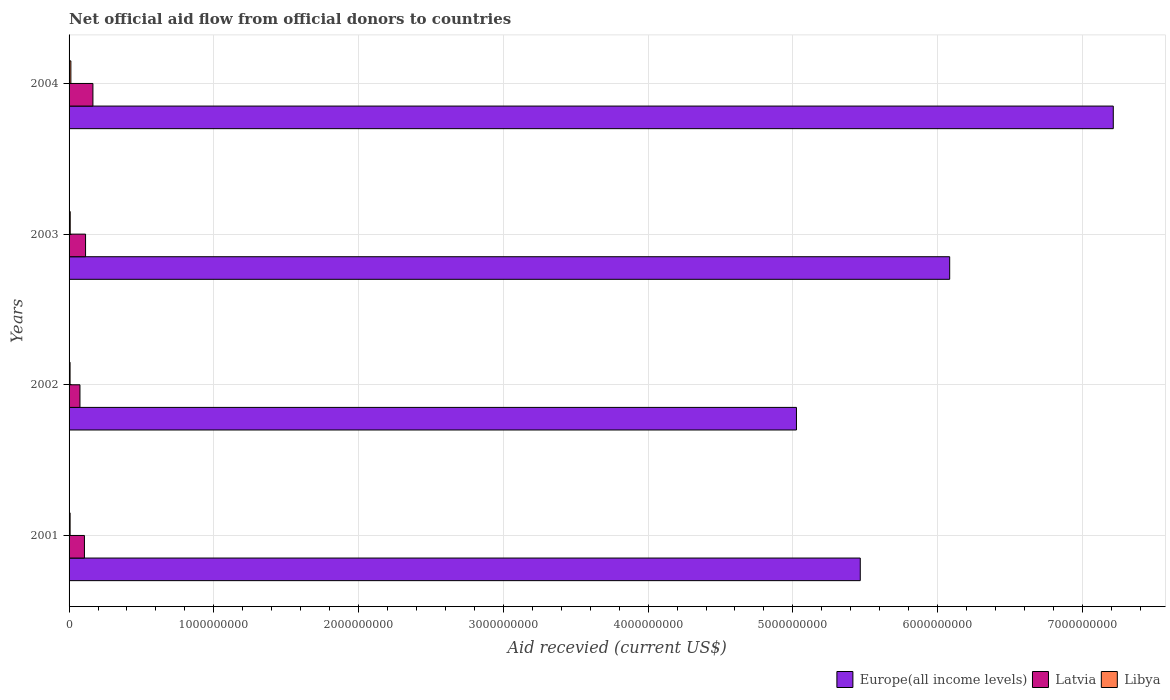How many different coloured bars are there?
Offer a terse response. 3. Are the number of bars per tick equal to the number of legend labels?
Ensure brevity in your answer.  Yes. Are the number of bars on each tick of the Y-axis equal?
Your response must be concise. Yes. How many bars are there on the 1st tick from the top?
Your answer should be very brief. 3. How many bars are there on the 4th tick from the bottom?
Provide a short and direct response. 3. In how many cases, is the number of bars for a given year not equal to the number of legend labels?
Your answer should be very brief. 0. What is the total aid received in Latvia in 2004?
Your answer should be very brief. 1.65e+08. Across all years, what is the maximum total aid received in Libya?
Keep it short and to the point. 1.24e+07. Across all years, what is the minimum total aid received in Europe(all income levels)?
Provide a succinct answer. 5.02e+09. What is the total total aid received in Latvia in the graph?
Provide a succinct answer. 4.60e+08. What is the difference between the total aid received in Europe(all income levels) in 2001 and that in 2003?
Offer a terse response. -6.18e+08. What is the difference between the total aid received in Libya in 2004 and the total aid received in Europe(all income levels) in 2003?
Keep it short and to the point. -6.07e+09. What is the average total aid received in Libya per year?
Keep it short and to the point. 8.60e+06. In the year 2001, what is the difference between the total aid received in Libya and total aid received in Europe(all income levels)?
Your answer should be compact. -5.46e+09. What is the ratio of the total aid received in Europe(all income levels) in 2001 to that in 2002?
Ensure brevity in your answer.  1.09. Is the difference between the total aid received in Libya in 2001 and 2004 greater than the difference between the total aid received in Europe(all income levels) in 2001 and 2004?
Keep it short and to the point. Yes. What is the difference between the highest and the second highest total aid received in Latvia?
Ensure brevity in your answer.  5.08e+07. What is the difference between the highest and the lowest total aid received in Libya?
Offer a very short reply. 5.55e+06. Is the sum of the total aid received in Latvia in 2002 and 2003 greater than the maximum total aid received in Europe(all income levels) across all years?
Provide a succinct answer. No. What does the 3rd bar from the top in 2002 represents?
Make the answer very short. Europe(all income levels). What does the 1st bar from the bottom in 2003 represents?
Give a very brief answer. Europe(all income levels). Are all the bars in the graph horizontal?
Keep it short and to the point. Yes. Are the values on the major ticks of X-axis written in scientific E-notation?
Provide a short and direct response. No. Does the graph contain grids?
Offer a terse response. Yes. How many legend labels are there?
Provide a succinct answer. 3. What is the title of the graph?
Offer a terse response. Net official aid flow from official donors to countries. What is the label or title of the X-axis?
Give a very brief answer. Aid recevied (current US$). What is the Aid recevied (current US$) in Europe(all income levels) in 2001?
Give a very brief answer. 5.47e+09. What is the Aid recevied (current US$) in Latvia in 2001?
Your answer should be very brief. 1.06e+08. What is the Aid recevied (current US$) in Libya in 2001?
Offer a very short reply. 7.14e+06. What is the Aid recevied (current US$) of Europe(all income levels) in 2002?
Your response must be concise. 5.02e+09. What is the Aid recevied (current US$) in Latvia in 2002?
Make the answer very short. 7.52e+07. What is the Aid recevied (current US$) in Libya in 2002?
Keep it short and to the point. 6.88e+06. What is the Aid recevied (current US$) in Europe(all income levels) in 2003?
Offer a terse response. 6.08e+09. What is the Aid recevied (current US$) in Latvia in 2003?
Your answer should be compact. 1.14e+08. What is the Aid recevied (current US$) of Libya in 2003?
Ensure brevity in your answer.  7.95e+06. What is the Aid recevied (current US$) of Europe(all income levels) in 2004?
Provide a succinct answer. 7.21e+09. What is the Aid recevied (current US$) of Latvia in 2004?
Your response must be concise. 1.65e+08. What is the Aid recevied (current US$) in Libya in 2004?
Your answer should be compact. 1.24e+07. Across all years, what is the maximum Aid recevied (current US$) of Europe(all income levels)?
Provide a succinct answer. 7.21e+09. Across all years, what is the maximum Aid recevied (current US$) of Latvia?
Provide a short and direct response. 1.65e+08. Across all years, what is the maximum Aid recevied (current US$) of Libya?
Provide a short and direct response. 1.24e+07. Across all years, what is the minimum Aid recevied (current US$) in Europe(all income levels)?
Your answer should be compact. 5.02e+09. Across all years, what is the minimum Aid recevied (current US$) in Latvia?
Offer a very short reply. 7.52e+07. Across all years, what is the minimum Aid recevied (current US$) of Libya?
Offer a very short reply. 6.88e+06. What is the total Aid recevied (current US$) of Europe(all income levels) in the graph?
Your answer should be compact. 2.38e+1. What is the total Aid recevied (current US$) in Latvia in the graph?
Provide a succinct answer. 4.60e+08. What is the total Aid recevied (current US$) in Libya in the graph?
Keep it short and to the point. 3.44e+07. What is the difference between the Aid recevied (current US$) in Europe(all income levels) in 2001 and that in 2002?
Your response must be concise. 4.41e+08. What is the difference between the Aid recevied (current US$) in Latvia in 2001 and that in 2002?
Keep it short and to the point. 3.09e+07. What is the difference between the Aid recevied (current US$) in Libya in 2001 and that in 2002?
Provide a succinct answer. 2.60e+05. What is the difference between the Aid recevied (current US$) of Europe(all income levels) in 2001 and that in 2003?
Provide a succinct answer. -6.18e+08. What is the difference between the Aid recevied (current US$) in Latvia in 2001 and that in 2003?
Give a very brief answer. -7.80e+06. What is the difference between the Aid recevied (current US$) in Libya in 2001 and that in 2003?
Ensure brevity in your answer.  -8.10e+05. What is the difference between the Aid recevied (current US$) of Europe(all income levels) in 2001 and that in 2004?
Provide a short and direct response. -1.75e+09. What is the difference between the Aid recevied (current US$) of Latvia in 2001 and that in 2004?
Ensure brevity in your answer.  -5.86e+07. What is the difference between the Aid recevied (current US$) in Libya in 2001 and that in 2004?
Your response must be concise. -5.29e+06. What is the difference between the Aid recevied (current US$) of Europe(all income levels) in 2002 and that in 2003?
Provide a succinct answer. -1.06e+09. What is the difference between the Aid recevied (current US$) of Latvia in 2002 and that in 2003?
Your response must be concise. -3.87e+07. What is the difference between the Aid recevied (current US$) of Libya in 2002 and that in 2003?
Provide a short and direct response. -1.07e+06. What is the difference between the Aid recevied (current US$) in Europe(all income levels) in 2002 and that in 2004?
Your answer should be very brief. -2.19e+09. What is the difference between the Aid recevied (current US$) in Latvia in 2002 and that in 2004?
Make the answer very short. -8.95e+07. What is the difference between the Aid recevied (current US$) in Libya in 2002 and that in 2004?
Your response must be concise. -5.55e+06. What is the difference between the Aid recevied (current US$) of Europe(all income levels) in 2003 and that in 2004?
Provide a succinct answer. -1.13e+09. What is the difference between the Aid recevied (current US$) in Latvia in 2003 and that in 2004?
Your answer should be compact. -5.08e+07. What is the difference between the Aid recevied (current US$) in Libya in 2003 and that in 2004?
Make the answer very short. -4.48e+06. What is the difference between the Aid recevied (current US$) of Europe(all income levels) in 2001 and the Aid recevied (current US$) of Latvia in 2002?
Keep it short and to the point. 5.39e+09. What is the difference between the Aid recevied (current US$) in Europe(all income levels) in 2001 and the Aid recevied (current US$) in Libya in 2002?
Ensure brevity in your answer.  5.46e+09. What is the difference between the Aid recevied (current US$) of Latvia in 2001 and the Aid recevied (current US$) of Libya in 2002?
Ensure brevity in your answer.  9.93e+07. What is the difference between the Aid recevied (current US$) of Europe(all income levels) in 2001 and the Aid recevied (current US$) of Latvia in 2003?
Keep it short and to the point. 5.35e+09. What is the difference between the Aid recevied (current US$) of Europe(all income levels) in 2001 and the Aid recevied (current US$) of Libya in 2003?
Your answer should be very brief. 5.46e+09. What is the difference between the Aid recevied (current US$) in Latvia in 2001 and the Aid recevied (current US$) in Libya in 2003?
Your answer should be very brief. 9.82e+07. What is the difference between the Aid recevied (current US$) of Europe(all income levels) in 2001 and the Aid recevied (current US$) of Latvia in 2004?
Keep it short and to the point. 5.30e+09. What is the difference between the Aid recevied (current US$) of Europe(all income levels) in 2001 and the Aid recevied (current US$) of Libya in 2004?
Offer a terse response. 5.45e+09. What is the difference between the Aid recevied (current US$) in Latvia in 2001 and the Aid recevied (current US$) in Libya in 2004?
Ensure brevity in your answer.  9.37e+07. What is the difference between the Aid recevied (current US$) of Europe(all income levels) in 2002 and the Aid recevied (current US$) of Latvia in 2003?
Keep it short and to the point. 4.91e+09. What is the difference between the Aid recevied (current US$) in Europe(all income levels) in 2002 and the Aid recevied (current US$) in Libya in 2003?
Your answer should be compact. 5.02e+09. What is the difference between the Aid recevied (current US$) of Latvia in 2002 and the Aid recevied (current US$) of Libya in 2003?
Ensure brevity in your answer.  6.72e+07. What is the difference between the Aid recevied (current US$) in Europe(all income levels) in 2002 and the Aid recevied (current US$) in Latvia in 2004?
Provide a succinct answer. 4.86e+09. What is the difference between the Aid recevied (current US$) in Europe(all income levels) in 2002 and the Aid recevied (current US$) in Libya in 2004?
Offer a very short reply. 5.01e+09. What is the difference between the Aid recevied (current US$) of Latvia in 2002 and the Aid recevied (current US$) of Libya in 2004?
Provide a short and direct response. 6.28e+07. What is the difference between the Aid recevied (current US$) in Europe(all income levels) in 2003 and the Aid recevied (current US$) in Latvia in 2004?
Keep it short and to the point. 5.92e+09. What is the difference between the Aid recevied (current US$) in Europe(all income levels) in 2003 and the Aid recevied (current US$) in Libya in 2004?
Your response must be concise. 6.07e+09. What is the difference between the Aid recevied (current US$) in Latvia in 2003 and the Aid recevied (current US$) in Libya in 2004?
Ensure brevity in your answer.  1.02e+08. What is the average Aid recevied (current US$) of Europe(all income levels) per year?
Offer a terse response. 5.95e+09. What is the average Aid recevied (current US$) of Latvia per year?
Give a very brief answer. 1.15e+08. What is the average Aid recevied (current US$) in Libya per year?
Your response must be concise. 8.60e+06. In the year 2001, what is the difference between the Aid recevied (current US$) in Europe(all income levels) and Aid recevied (current US$) in Latvia?
Make the answer very short. 5.36e+09. In the year 2001, what is the difference between the Aid recevied (current US$) in Europe(all income levels) and Aid recevied (current US$) in Libya?
Ensure brevity in your answer.  5.46e+09. In the year 2001, what is the difference between the Aid recevied (current US$) in Latvia and Aid recevied (current US$) in Libya?
Give a very brief answer. 9.90e+07. In the year 2002, what is the difference between the Aid recevied (current US$) in Europe(all income levels) and Aid recevied (current US$) in Latvia?
Your answer should be very brief. 4.95e+09. In the year 2002, what is the difference between the Aid recevied (current US$) of Europe(all income levels) and Aid recevied (current US$) of Libya?
Keep it short and to the point. 5.02e+09. In the year 2002, what is the difference between the Aid recevied (current US$) of Latvia and Aid recevied (current US$) of Libya?
Make the answer very short. 6.83e+07. In the year 2003, what is the difference between the Aid recevied (current US$) of Europe(all income levels) and Aid recevied (current US$) of Latvia?
Provide a short and direct response. 5.97e+09. In the year 2003, what is the difference between the Aid recevied (current US$) in Europe(all income levels) and Aid recevied (current US$) in Libya?
Offer a very short reply. 6.08e+09. In the year 2003, what is the difference between the Aid recevied (current US$) of Latvia and Aid recevied (current US$) of Libya?
Your answer should be compact. 1.06e+08. In the year 2004, what is the difference between the Aid recevied (current US$) of Europe(all income levels) and Aid recevied (current US$) of Latvia?
Ensure brevity in your answer.  7.05e+09. In the year 2004, what is the difference between the Aid recevied (current US$) in Europe(all income levels) and Aid recevied (current US$) in Libya?
Provide a short and direct response. 7.20e+09. In the year 2004, what is the difference between the Aid recevied (current US$) of Latvia and Aid recevied (current US$) of Libya?
Your answer should be very brief. 1.52e+08. What is the ratio of the Aid recevied (current US$) of Europe(all income levels) in 2001 to that in 2002?
Keep it short and to the point. 1.09. What is the ratio of the Aid recevied (current US$) in Latvia in 2001 to that in 2002?
Keep it short and to the point. 1.41. What is the ratio of the Aid recevied (current US$) of Libya in 2001 to that in 2002?
Ensure brevity in your answer.  1.04. What is the ratio of the Aid recevied (current US$) in Europe(all income levels) in 2001 to that in 2003?
Give a very brief answer. 0.9. What is the ratio of the Aid recevied (current US$) of Latvia in 2001 to that in 2003?
Offer a terse response. 0.93. What is the ratio of the Aid recevied (current US$) of Libya in 2001 to that in 2003?
Offer a terse response. 0.9. What is the ratio of the Aid recevied (current US$) of Europe(all income levels) in 2001 to that in 2004?
Ensure brevity in your answer.  0.76. What is the ratio of the Aid recevied (current US$) in Latvia in 2001 to that in 2004?
Your answer should be compact. 0.64. What is the ratio of the Aid recevied (current US$) in Libya in 2001 to that in 2004?
Offer a very short reply. 0.57. What is the ratio of the Aid recevied (current US$) of Europe(all income levels) in 2002 to that in 2003?
Your answer should be very brief. 0.83. What is the ratio of the Aid recevied (current US$) in Latvia in 2002 to that in 2003?
Provide a succinct answer. 0.66. What is the ratio of the Aid recevied (current US$) in Libya in 2002 to that in 2003?
Your answer should be compact. 0.87. What is the ratio of the Aid recevied (current US$) of Europe(all income levels) in 2002 to that in 2004?
Provide a succinct answer. 0.7. What is the ratio of the Aid recevied (current US$) of Latvia in 2002 to that in 2004?
Provide a short and direct response. 0.46. What is the ratio of the Aid recevied (current US$) in Libya in 2002 to that in 2004?
Provide a short and direct response. 0.55. What is the ratio of the Aid recevied (current US$) in Europe(all income levels) in 2003 to that in 2004?
Offer a very short reply. 0.84. What is the ratio of the Aid recevied (current US$) of Latvia in 2003 to that in 2004?
Your answer should be very brief. 0.69. What is the ratio of the Aid recevied (current US$) in Libya in 2003 to that in 2004?
Offer a terse response. 0.64. What is the difference between the highest and the second highest Aid recevied (current US$) in Europe(all income levels)?
Your response must be concise. 1.13e+09. What is the difference between the highest and the second highest Aid recevied (current US$) of Latvia?
Your answer should be compact. 5.08e+07. What is the difference between the highest and the second highest Aid recevied (current US$) in Libya?
Make the answer very short. 4.48e+06. What is the difference between the highest and the lowest Aid recevied (current US$) of Europe(all income levels)?
Offer a terse response. 2.19e+09. What is the difference between the highest and the lowest Aid recevied (current US$) in Latvia?
Ensure brevity in your answer.  8.95e+07. What is the difference between the highest and the lowest Aid recevied (current US$) of Libya?
Provide a short and direct response. 5.55e+06. 